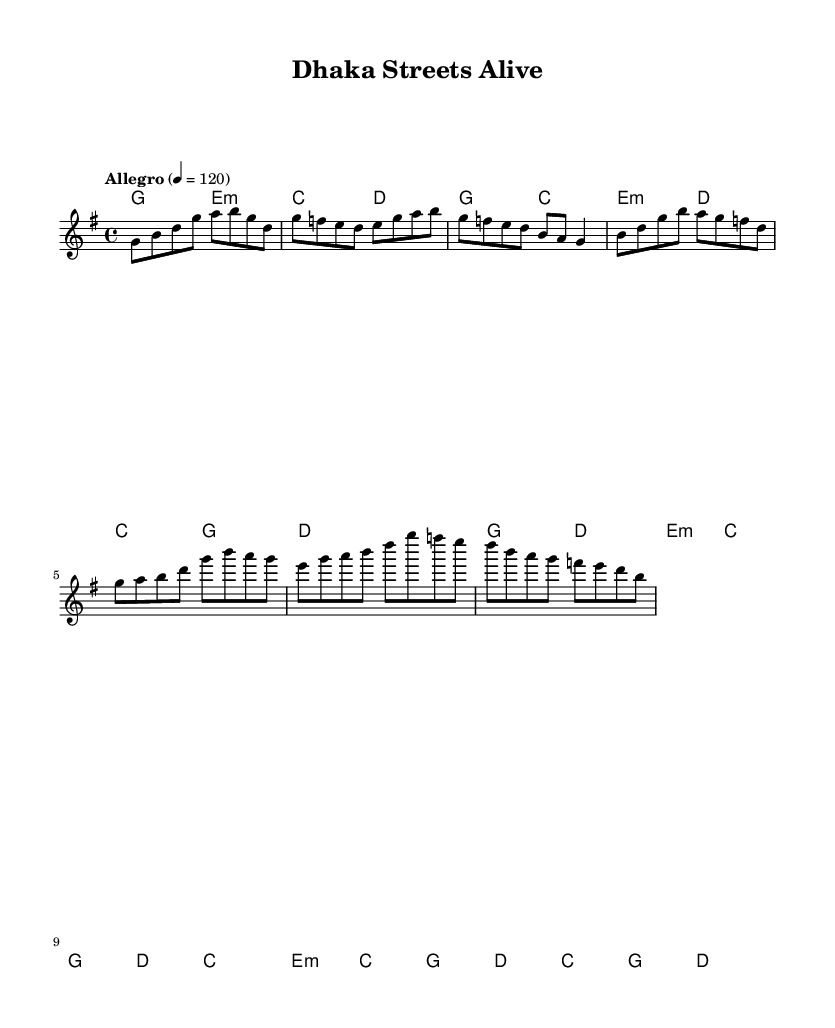What is the key signature of this music? The key signature is G major, which has one sharp (F#). This can be determined as there is a single sharp indicated on the staff at the beginning of the score.
Answer: G major What is the time signature of this music? The time signature is 4/4, which is indicated next to the clef at the beginning of the score. This means there are four beats in each measure and each quarter note receives one beat.
Answer: 4/4 What is the tempo marking of this piece? The tempo marking is "Allegro" with a metronome marking of 120 beats per minute. This indicates the piece should be played in a fast and lively manner, specifically at 120 quarter note beats per minute.
Answer: Allegro, 120 How many measures are in the verse section? The verse section contains three measures. Each measure is visually separated in the music sheet by vertical lines, and by counting these, we determine that there are three for the verse.
Answer: 3 What is the first chord in the score? The first chord is G major. This is identified by looking at the chord symbols above the staff in the section marked "Intro," where the first symbol is "g."
Answer: G major What is the structure of the music based on sections? The structure consists of an Intro, Verse, Chorus, and Bridge. By examining the layout of the music, we can categorize the sections according to their respective labels, showcasing the format of the piece.
Answer: Intro, Verse, Chorus, Bridge Which element indicates the music is a fusion of Western pop and Bengali folk? The melodic lines exhibit characteristics of both Western pop and traditional Bengali folk, such as rhythmic diversity and ornamentation. This can be inferred from the blend of melodies and harmonies utilized throughout the piece.
Answer: Melodic lines 